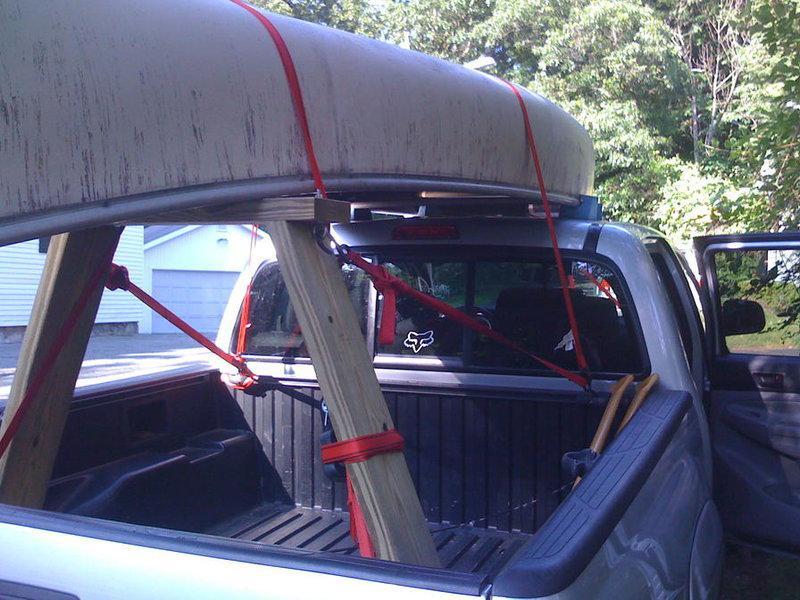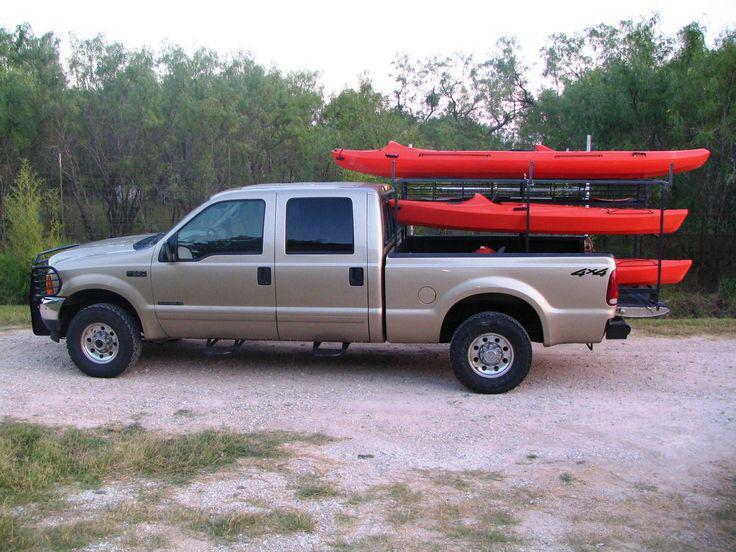The first image is the image on the left, the second image is the image on the right. Analyze the images presented: Is the assertion "In one image, a pickup truck has two different-colored boats loaded on an overhead rack." valid? Answer yes or no. No. 